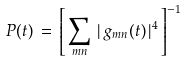<formula> <loc_0><loc_0><loc_500><loc_500>P ( t ) \, = \, \left [ \, \sum _ { m n } \, | \, g _ { m n } ( t ) \, | ^ { 4 } \, \right ] ^ { - 1 }</formula> 